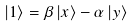<formula> <loc_0><loc_0><loc_500><loc_500>\left | 1 \right \rangle = \beta \left | x \right \rangle - \alpha \left | y \right \rangle</formula> 